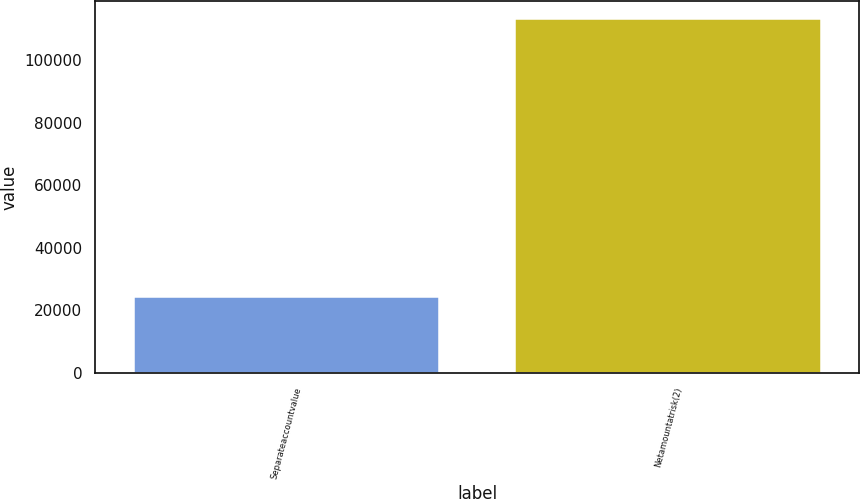Convert chart. <chart><loc_0><loc_0><loc_500><loc_500><bar_chart><fcel>Separateaccountvalue<fcel>Netamountatrisk(2)<nl><fcel>24328<fcel>113124<nl></chart> 